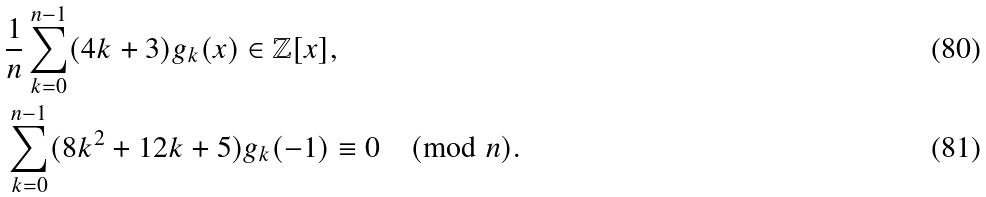<formula> <loc_0><loc_0><loc_500><loc_500>& \frac { 1 } { n } \sum _ { k = 0 } ^ { n - 1 } ( 4 k + 3 ) g _ { k } ( x ) \in \mathbb { Z } [ x ] , \quad \\ & \sum _ { k = 0 } ^ { n - 1 } ( 8 k ^ { 2 } + 1 2 k + 5 ) g _ { k } ( - 1 ) \equiv 0 \pmod { n } .</formula> 